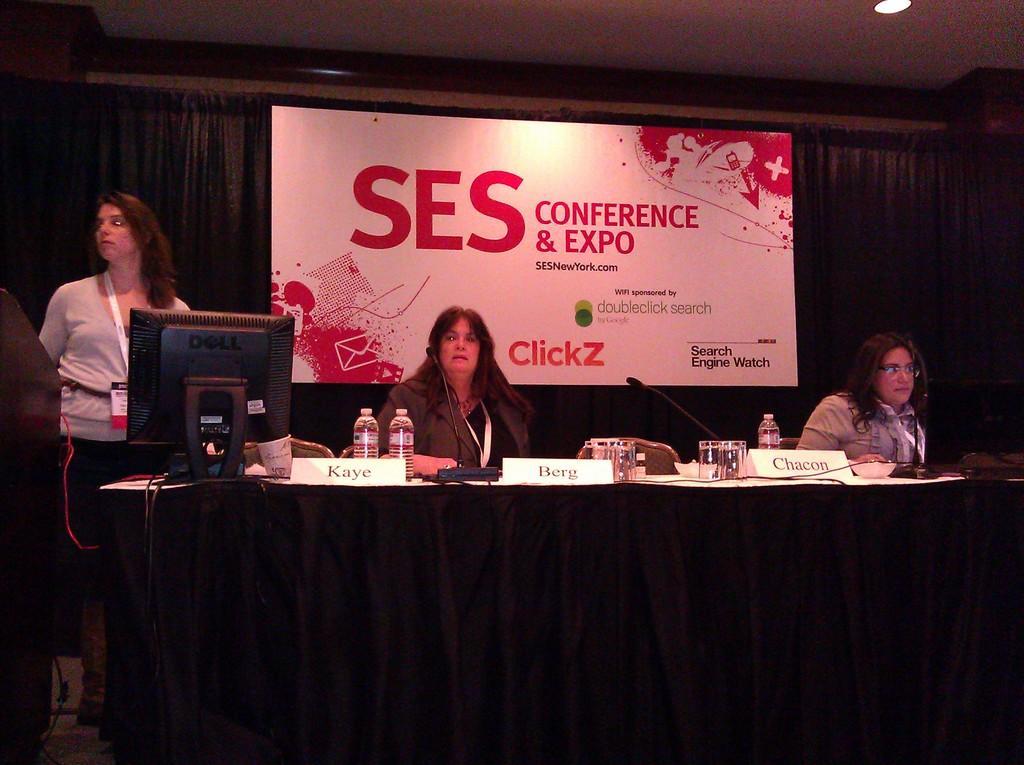How would you summarize this image in a sentence or two? In this image, we can see persons in front of the table. This table contains glasses and bottles. There is an another person on the left side of the image standing in front of the monitor. There is a banner in the middle of the image. There is a ceiling at the top of the image. 